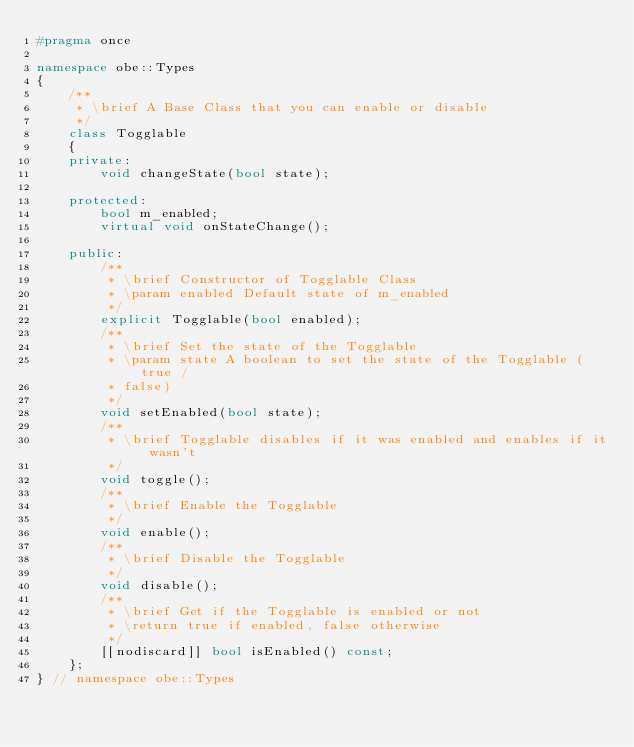Convert code to text. <code><loc_0><loc_0><loc_500><loc_500><_C++_>#pragma once

namespace obe::Types
{
    /**
     * \brief A Base Class that you can enable or disable
     */
    class Togglable
    {
    private:
        void changeState(bool state);

    protected:
        bool m_enabled;
        virtual void onStateChange();

    public:
        /**
         * \brief Constructor of Togglable Class
         * \param enabled Default state of m_enabled
         */
        explicit Togglable(bool enabled);
        /**
         * \brief Set the state of the Togglable
         * \param state A boolean to set the state of the Togglable (true /
         * false)
         */
        void setEnabled(bool state);
        /**
         * \brief Togglable disables if it was enabled and enables if it wasn't
         */
        void toggle();
        /**
         * \brief Enable the Togglable
         */
        void enable();
        /**
         * \brief Disable the Togglable
         */
        void disable();
        /**
         * \brief Get if the Togglable is enabled or not
         * \return true if enabled, false otherwise
         */
        [[nodiscard]] bool isEnabled() const;
    };
} // namespace obe::Types</code> 